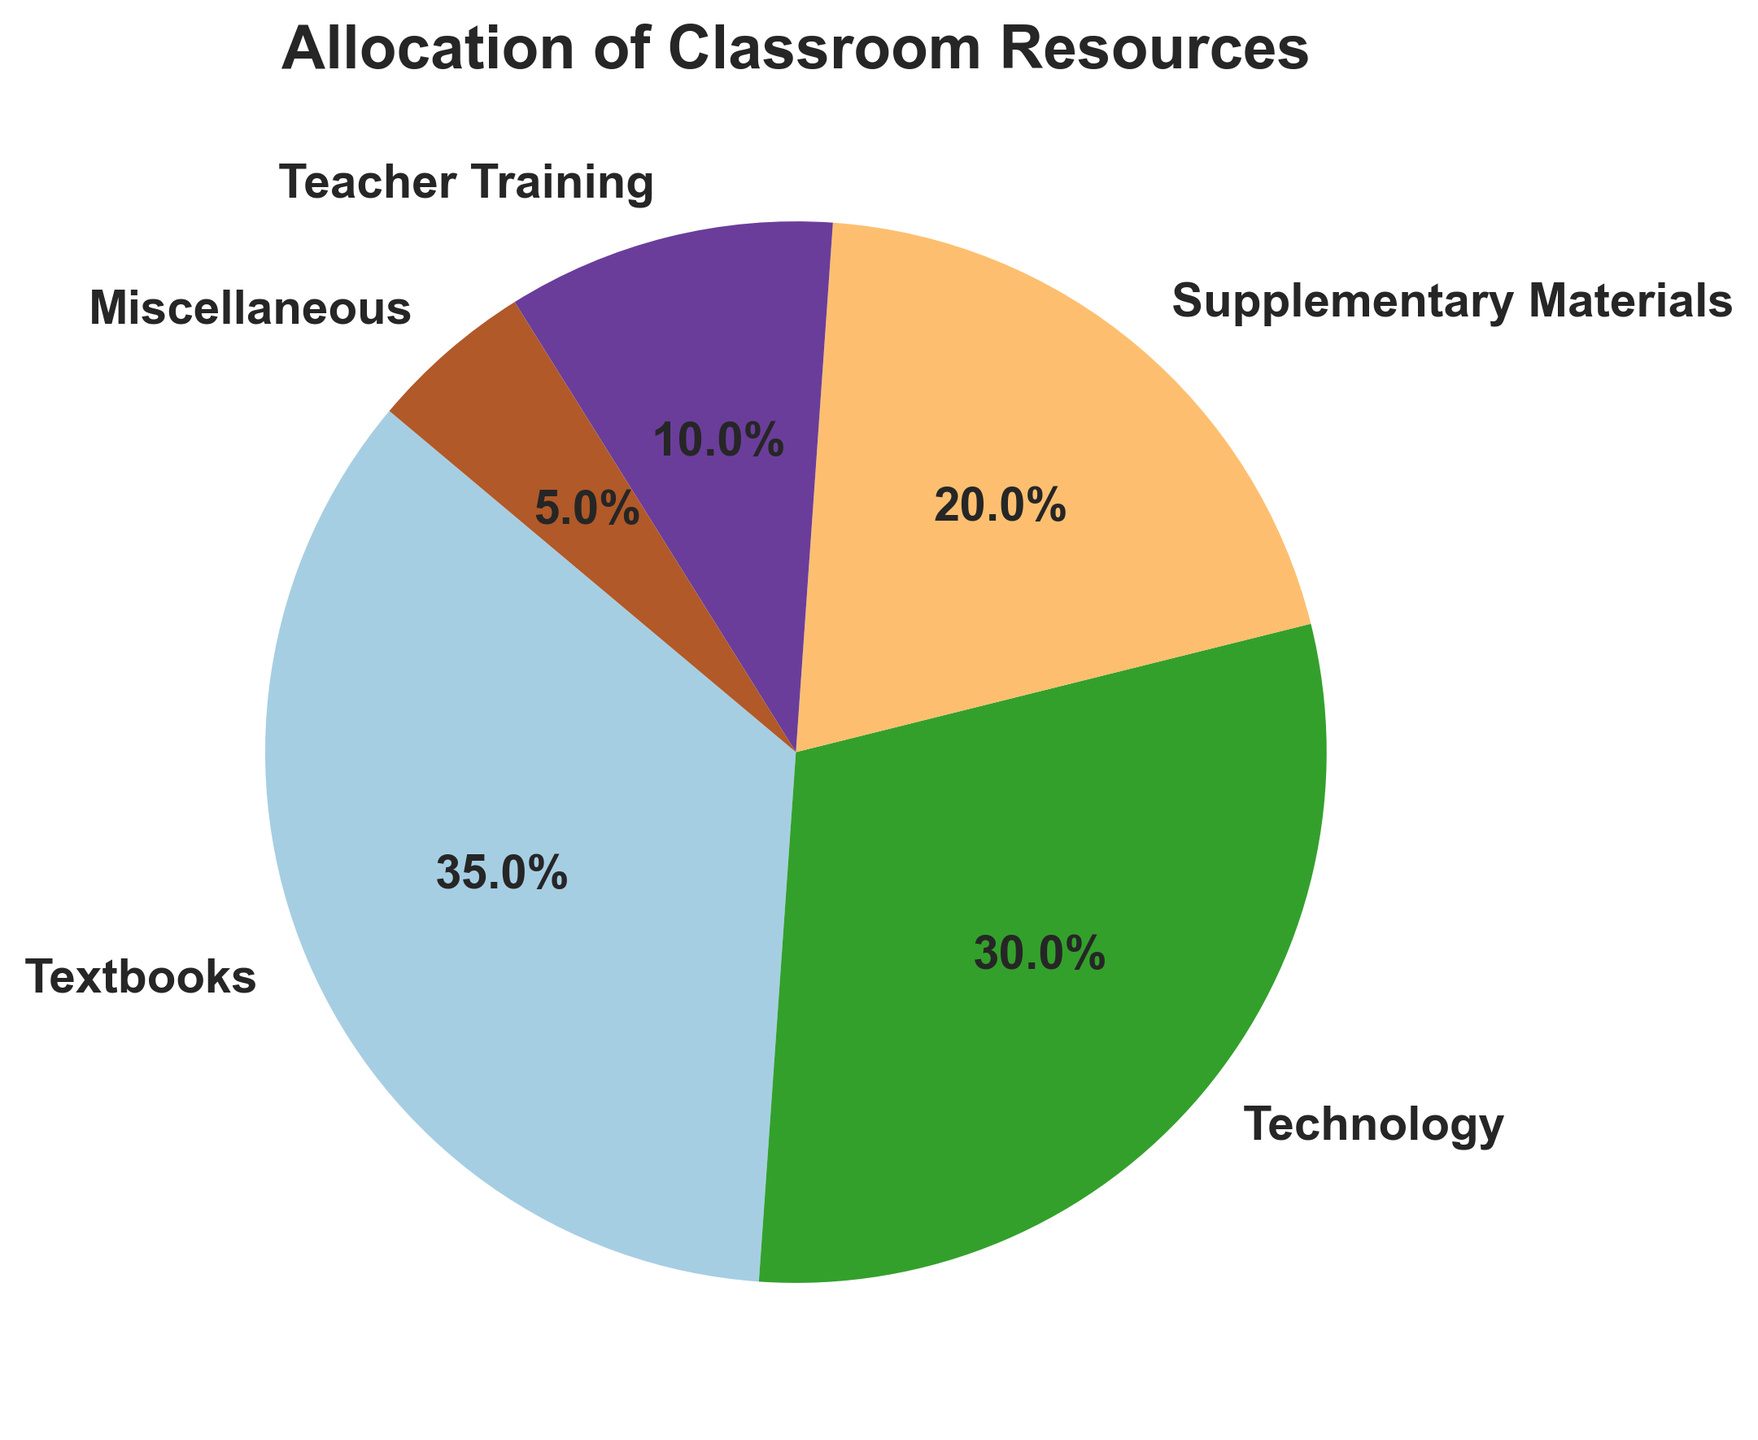What percentage of the classroom resources is allocated to teacher training and supplementary materials combined? First, identify the percentages for teacher training (10%) and supplementary materials (20%). Then add these two percentages together: 10% + 20% = 30%.
Answer: 30% Which category has the second highest allocation of classroom resources? Review the percentages for each category. The highest is textbooks (35%), and the second highest is technology (30%).
Answer: Technology How much more is allocated to textbooks compared to miscellaneous resources? Identify the percentages for textbooks (35%) and miscellaneous (5%). Subtract the percentage for miscellaneous from textbooks: 35% - 5% = 30%.
Answer: 30% Are technology resources allocated more or less than supplementary materials? By how much? Compare the percentages for technology (30%) and supplementary materials (20%). Technology is allocated more. Subtract the percentage for supplementary materials from technology: 30% - 20% = 10%.
Answer: More, by 10% What is the smallest allocation category in the pie chart, and what percentage does it represent? Review the percentages for each category. The smallest allocation is miscellaneous, which represents 5%.
Answer: Miscellaneous, 5% What is the combined allocation percentage for textbooks and technology? Identify the percentages for textbooks (35%) and technology (30%). Add these two percentages together: 35% + 30% = 65%.
Answer: 65% Which category is given the primary focus in terms of allocation, and what percentage does it represent? Review the percentages for each category. The primary focus is on textbooks, which represents 35%.
Answer: Textbooks, 35% If the total budget for classroom resources is $100,000, how much funding is allocated to supplementary materials? Calculate 20% of $100,000. \(( 20 / 100 ) * 100000 = 20000 \textit{ dollars}\) . Therefore, $20,000 is allocated to supplementary materials.
Answer: $20,000 How many percentage points less is allocated to teacher training compared to textbooks? Identify the percentages for teacher training (10%) and textbooks (35%). Subtract the percentage for teacher training from textbooks: 35% - 10% = 25%.
Answer: 25% 